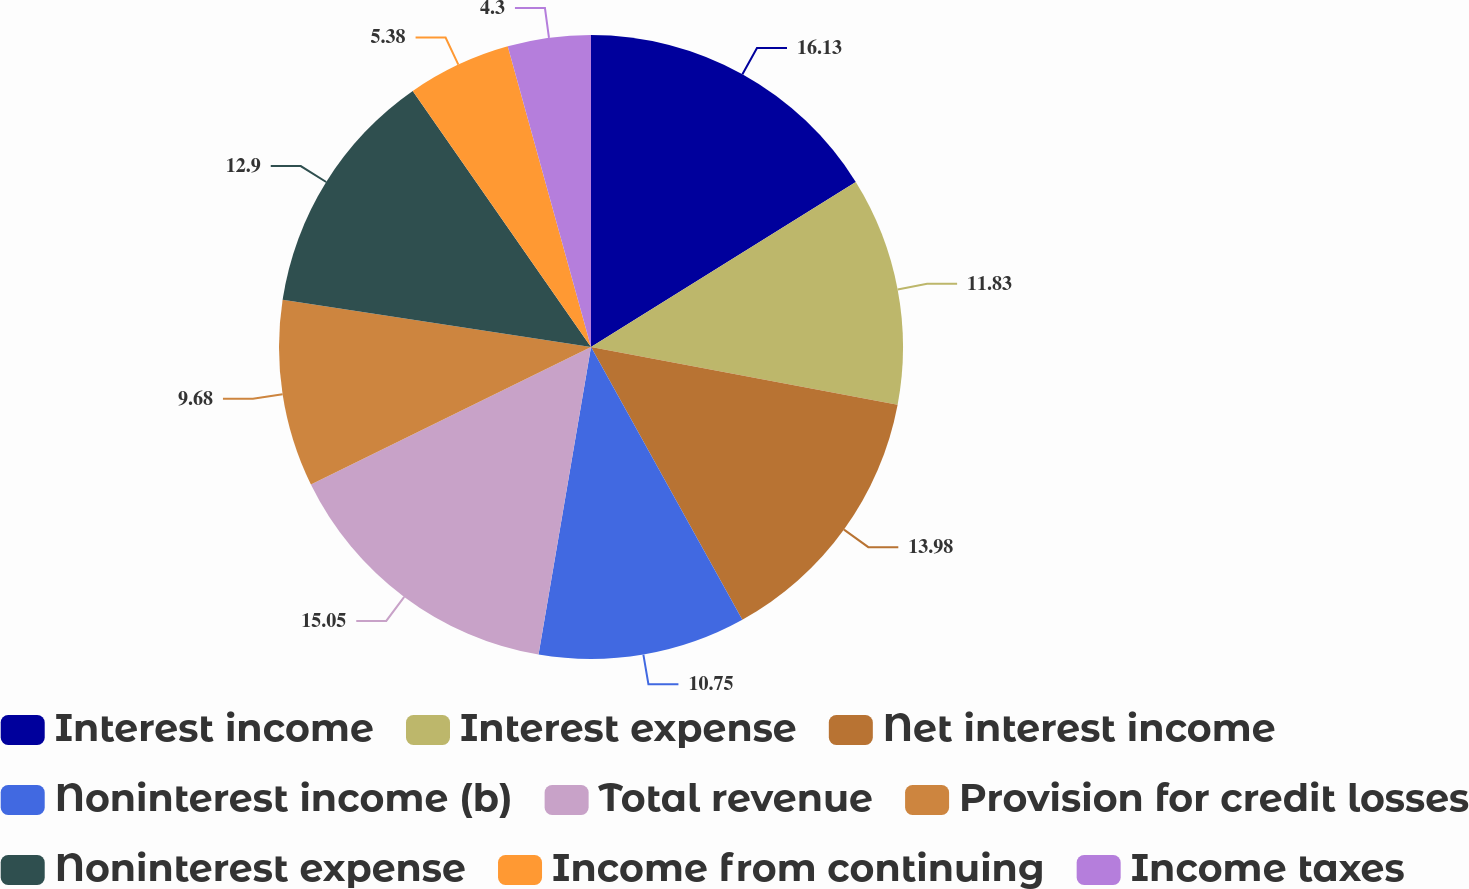Convert chart. <chart><loc_0><loc_0><loc_500><loc_500><pie_chart><fcel>Interest income<fcel>Interest expense<fcel>Net interest income<fcel>Noninterest income (b)<fcel>Total revenue<fcel>Provision for credit losses<fcel>Noninterest expense<fcel>Income from continuing<fcel>Income taxes<nl><fcel>16.13%<fcel>11.83%<fcel>13.98%<fcel>10.75%<fcel>15.05%<fcel>9.68%<fcel>12.9%<fcel>5.38%<fcel>4.3%<nl></chart> 